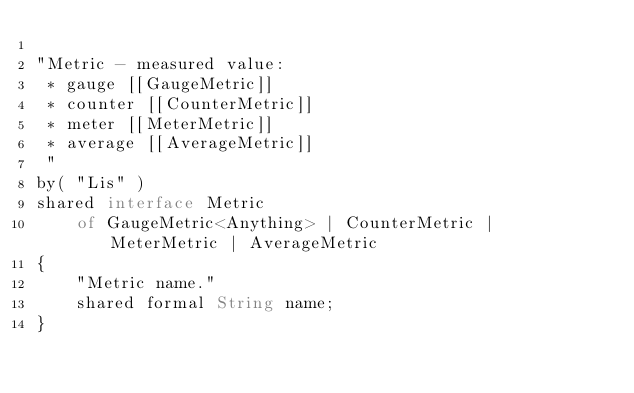Convert code to text. <code><loc_0><loc_0><loc_500><loc_500><_Ceylon_>
"Metric - measured value:
 * gauge [[GaugeMetric]]
 * counter [[CounterMetric]]
 * meter [[MeterMetric]]
 * average [[AverageMetric]]
 "
by( "Lis" )
shared interface Metric
	of GaugeMetric<Anything> | CounterMetric | MeterMetric | AverageMetric
{
	"Metric name."
	shared formal String name;
}
</code> 